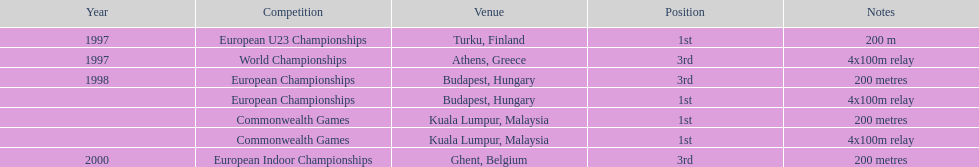How many competitions were in budapest, hungary and came in 1st position? 1. 